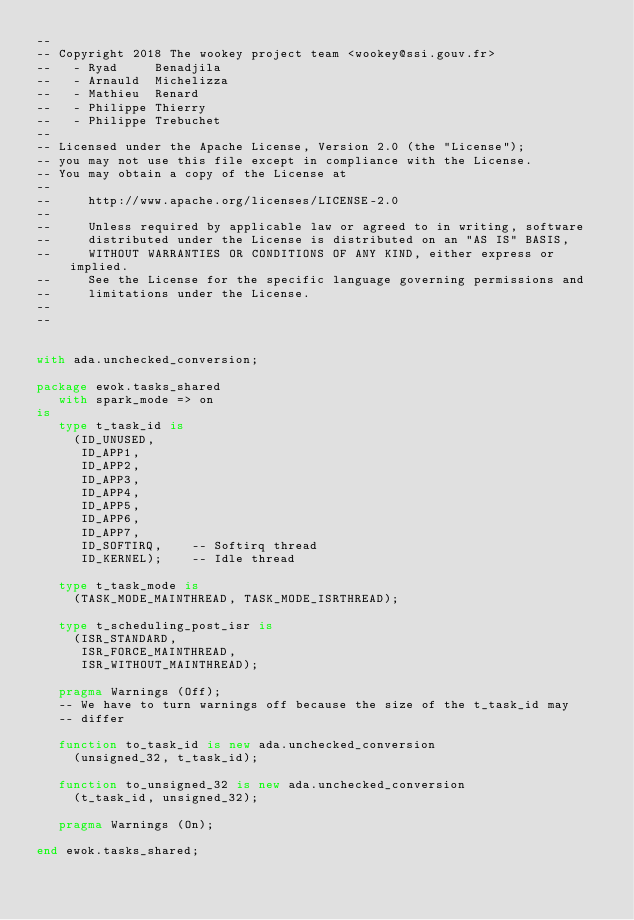<code> <loc_0><loc_0><loc_500><loc_500><_Ada_>--
-- Copyright 2018 The wookey project team <wookey@ssi.gouv.fr>
--   - Ryad     Benadjila
--   - Arnauld  Michelizza
--   - Mathieu  Renard
--   - Philippe Thierry
--   - Philippe Trebuchet
--
-- Licensed under the Apache License, Version 2.0 (the "License");
-- you may not use this file except in compliance with the License.
-- You may obtain a copy of the License at
--
--     http://www.apache.org/licenses/LICENSE-2.0
--
--     Unless required by applicable law or agreed to in writing, software
--     distributed under the License is distributed on an "AS IS" BASIS,
--     WITHOUT WARRANTIES OR CONDITIONS OF ANY KIND, either express or implied.
--     See the License for the specific language governing permissions and
--     limitations under the License.
--
--


with ada.unchecked_conversion;

package ewok.tasks_shared
   with spark_mode => on
is
   type t_task_id is
     (ID_UNUSED,
      ID_APP1,
      ID_APP2,
      ID_APP3,
      ID_APP4,
      ID_APP5,
      ID_APP6,
      ID_APP7,
      ID_SOFTIRQ,    -- Softirq thread 
      ID_KERNEL);    -- Idle thread

   type t_task_mode is
     (TASK_MODE_MAINTHREAD, TASK_MODE_ISRTHREAD);

   type t_scheduling_post_isr is
     (ISR_STANDARD,
      ISR_FORCE_MAINTHREAD,
      ISR_WITHOUT_MAINTHREAD);

   pragma Warnings (Off);
   -- We have to turn warnings off because the size of the t_task_id may
   -- differ

   function to_task_id is new ada.unchecked_conversion
     (unsigned_32, t_task_id);

   function to_unsigned_32 is new ada.unchecked_conversion
     (t_task_id, unsigned_32);

   pragma Warnings (On);

end ewok.tasks_shared;
</code> 